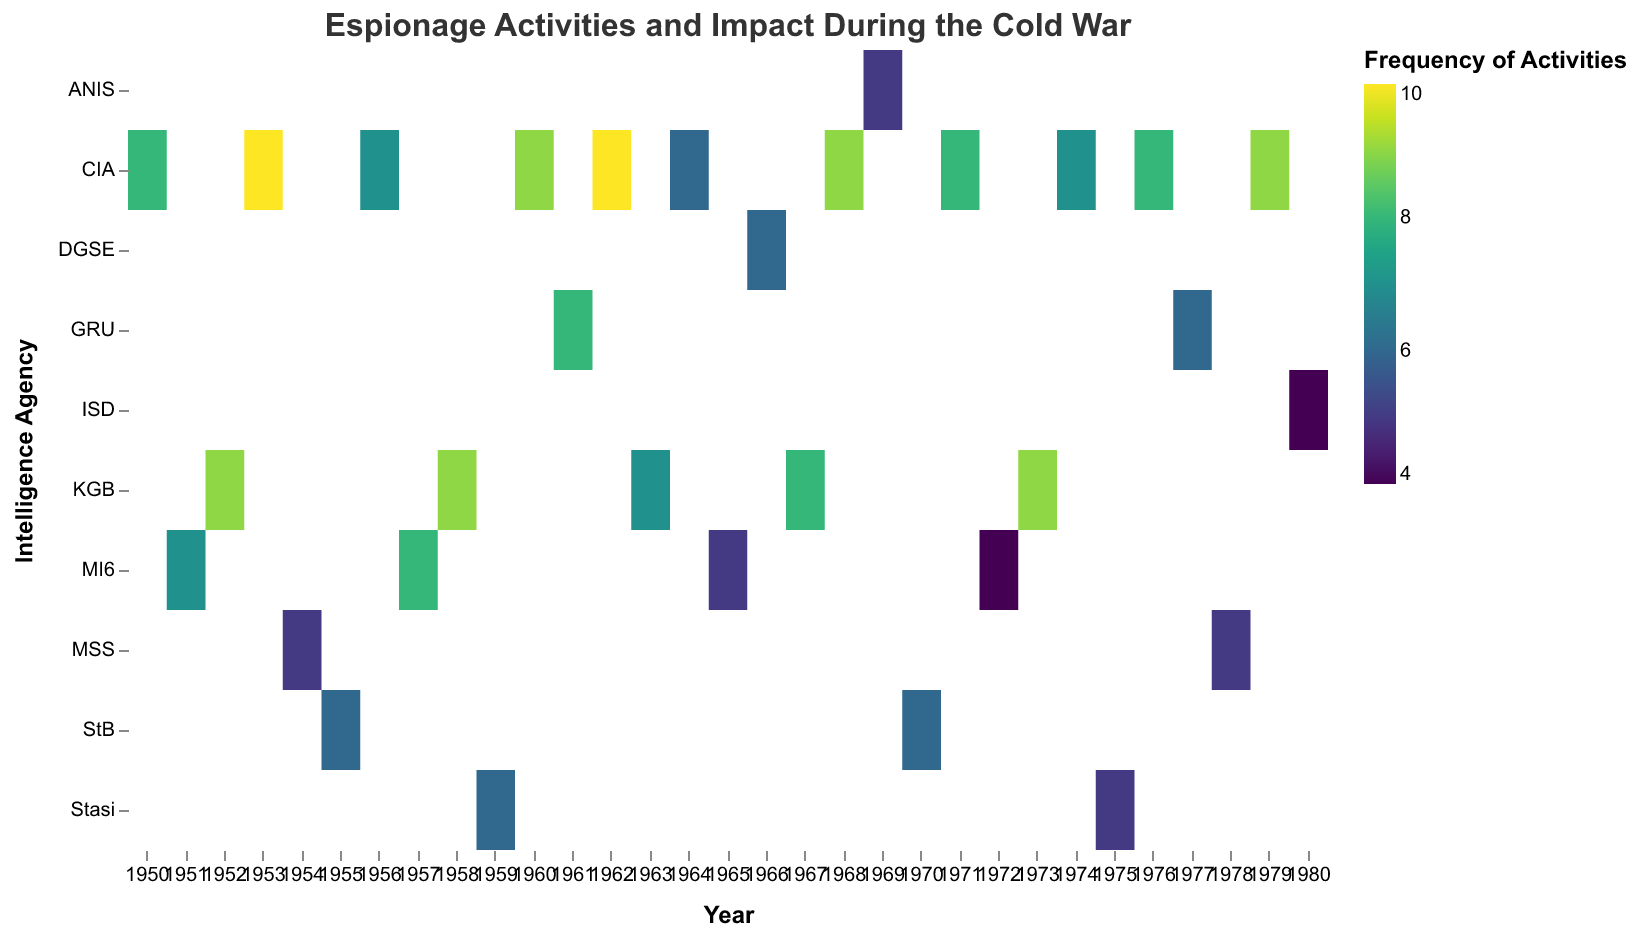What is the title of the heatmap? The title of the heatmap is mentioned at the top in the heatmap. It is "Espionage Activities and Impact During the Cold War"
Answer: Espionage Activities and Impact During the Cold War How many intelligence agencies are represented in the heatmap? The y-axis lists all the intelligence agencies that are represented. By counting the unique labels on the y-axis, we identify that there are 11 intelligence agencies represented.
Answer: 11 In which year did the CIA have the highest frequency of espionage activities, and in what policy area? By looking at the color intensity of the cells corresponding to the CIA on the y-axis and finding the year with the darkest color, we can identify that in 1962, CIA had the highest frequency of espionage activities in the policy area of Regime_Change.
Answer: 1962, Regime_Change Compare the frequency of espionage activities between CIA and KGB in 1973. Which intelligence agency has a higher frequency and by how much? Locate the cells corresponding to CIA and KGB in 1973 and compare the values. The frequency for CIA in 1973 is missing, while KGB has a frequency of 9 in the policy area of Espionage_Networks. Thus, KGB has a higher frequency by 9.
Answer: KGB, 9 What is the most frequent impact level for espionage activities by MI6? By examining the tooltip information and the cells for MI6, we see most cells for MI6 are in Policy_Area with the “Medium” impact level.
Answer: Medium What is the total frequency of espionage activities performed by the CIA across all years? Sum all the frequency values corresponding to the rows of the CIA: 8 + 10 + 7 + 9 + 10 + 6 + 9 + 9 + 8 + 7 + 8 + 9 = 100.
Answer: 100 Which intelligence agency had espionage activities in the policy area of Border_Controls and what was the frequency? By finding the cell corresponding to the policy area of Border Controls, we can see Stasi had espionage activities in this area with a frequency of 5 in 1975.
Answer: Stasi, 5 Which policy area has the highest cumulative impact level labeled as "High" across all intelligence agencies and years? Calculating the cumulative impact for each policy area by summing the frequencies where the impact level is "High", we see that Regime Change under CIA in 1962 and 1968 has the highest with a frequency of 10 and 9 respectively - making 19.
Answer: Regime Change, 19 How did the frequency of espionage activities fluctuate for the CIA in the decade of the 1960s? Identify the frequency values for CIA from 1960 to 1969: 9 (1960), 10 (1962), 6 (1964), 9 (1968), 8 (1971). We analyze this trend shows fluctuations but generally maintains high frequency.
Answer: Varied, generally high Which intelligence agency's espionage activities were most frequently involved in Covert Operations, and what was the frequency and the impact level? Locate the cell corresponding to Covert Operations and the intelligence agency involved, the CIA, with a frequency of 8 in 1976 and an impact level of High.
Answer: CIA, 8, High 